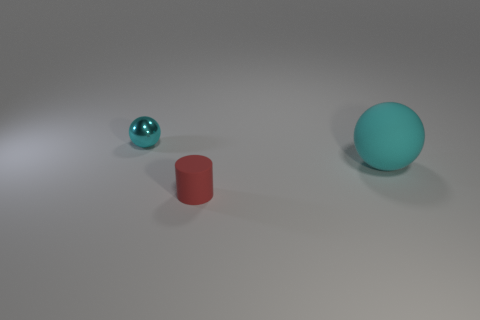Add 1 tiny matte objects. How many objects exist? 4 Subtract all spheres. How many objects are left? 1 Add 3 cyan things. How many cyan things are left? 5 Add 2 small blue metallic objects. How many small blue metallic objects exist? 2 Subtract 0 gray balls. How many objects are left? 3 Subtract all red spheres. Subtract all rubber spheres. How many objects are left? 2 